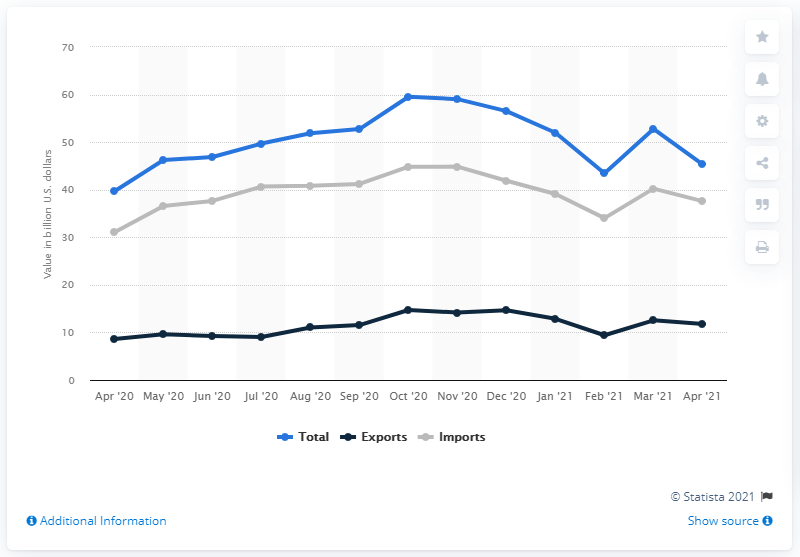Give some essential details in this illustration. In April 2021, the U.S. dollar import value amounted to $37.59. In April 2021, the total value of U.S. trade in goods with China was approximately $45.35 billion. 